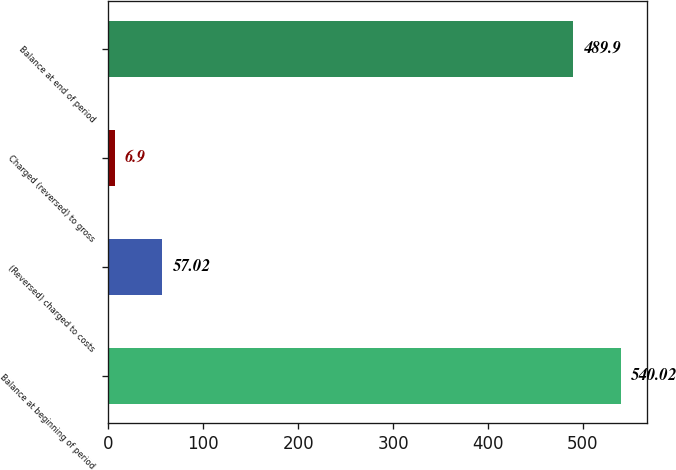Convert chart to OTSL. <chart><loc_0><loc_0><loc_500><loc_500><bar_chart><fcel>Balance at beginning of period<fcel>(Reversed) charged to costs<fcel>Charged (reversed) to gross<fcel>Balance at end of period<nl><fcel>540.02<fcel>57.02<fcel>6.9<fcel>489.9<nl></chart> 